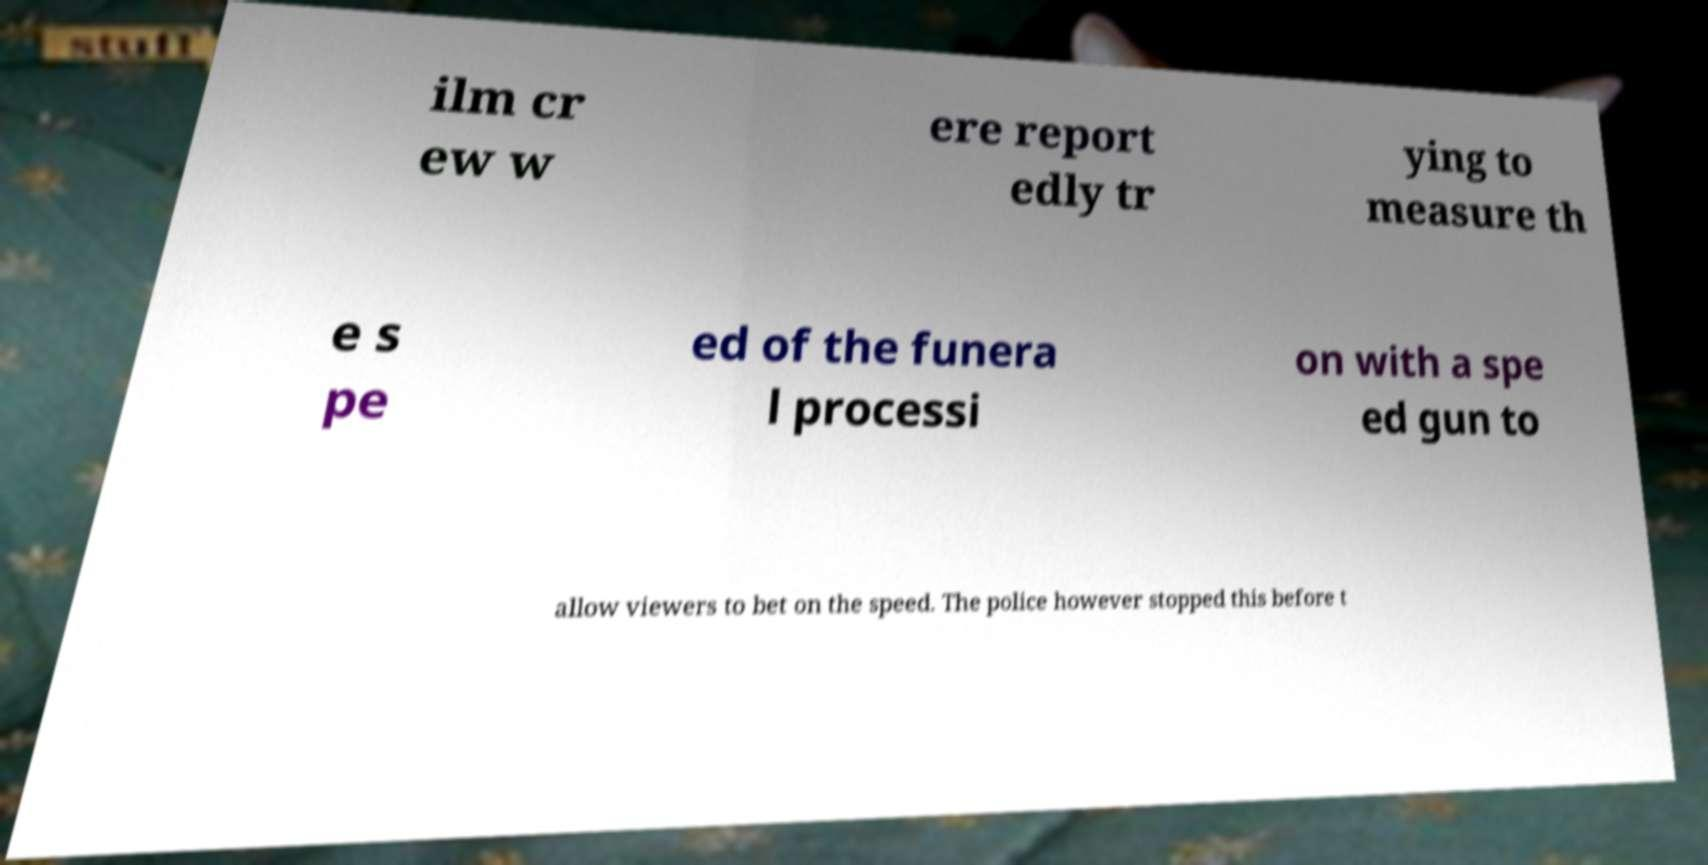I need the written content from this picture converted into text. Can you do that? ilm cr ew w ere report edly tr ying to measure th e s pe ed of the funera l processi on with a spe ed gun to allow viewers to bet on the speed. The police however stopped this before t 